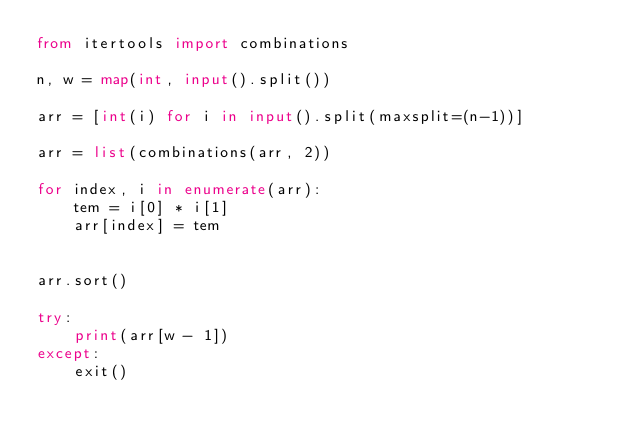<code> <loc_0><loc_0><loc_500><loc_500><_Python_>from itertools import combinations

n, w = map(int, input().split())

arr = [int(i) for i in input().split(maxsplit=(n-1))]

arr = list(combinations(arr, 2))

for index, i in enumerate(arr):
    tem = i[0] * i[1]
    arr[index] = tem


arr.sort()

try:
    print(arr[w - 1])
except:
    exit()
</code> 